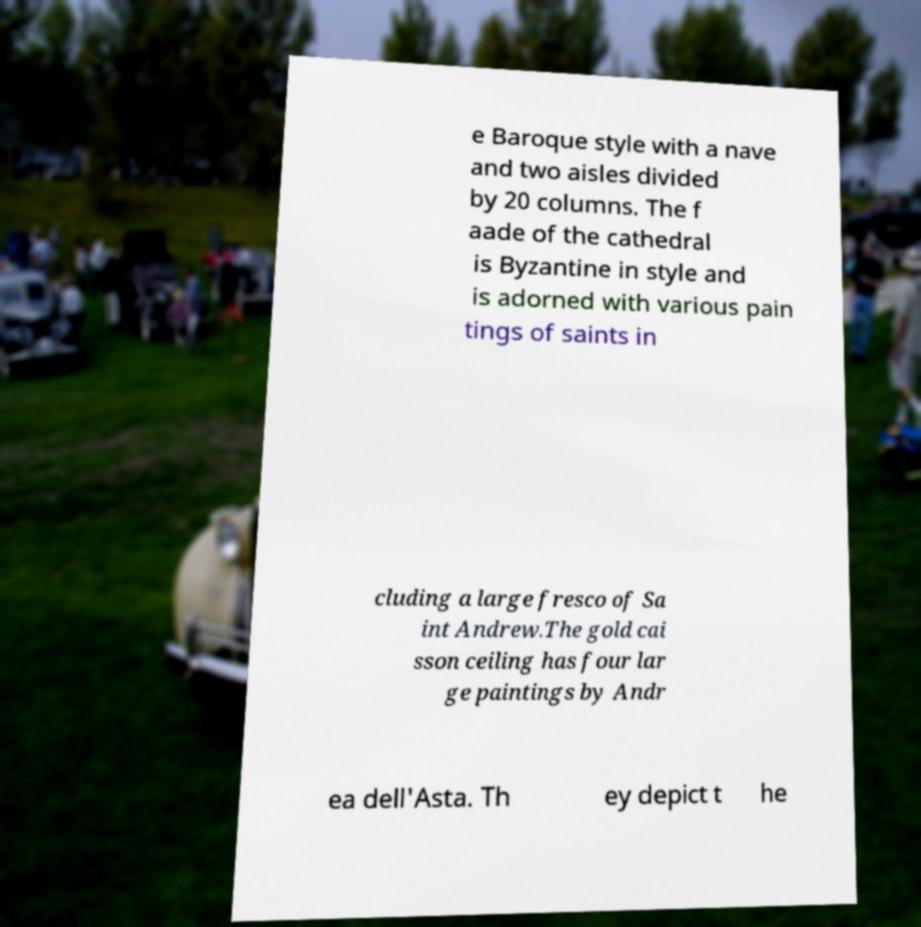What messages or text are displayed in this image? I need them in a readable, typed format. e Baroque style with a nave and two aisles divided by 20 columns. The f aade of the cathedral is Byzantine in style and is adorned with various pain tings of saints in cluding a large fresco of Sa int Andrew.The gold cai sson ceiling has four lar ge paintings by Andr ea dell'Asta. Th ey depict t he 